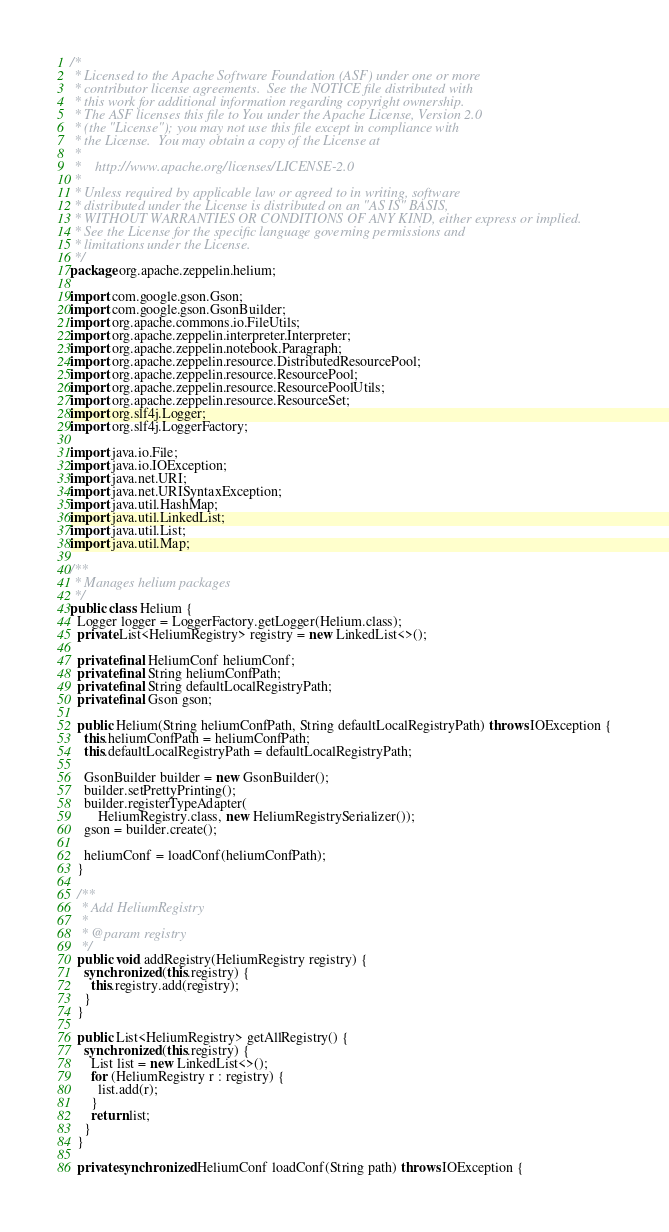Convert code to text. <code><loc_0><loc_0><loc_500><loc_500><_Java_>/*
 * Licensed to the Apache Software Foundation (ASF) under one or more
 * contributor license agreements.  See the NOTICE file distributed with
 * this work for additional information regarding copyright ownership.
 * The ASF licenses this file to You under the Apache License, Version 2.0
 * (the "License"); you may not use this file except in compliance with
 * the License.  You may obtain a copy of the License at
 *
 *    http://www.apache.org/licenses/LICENSE-2.0
 *
 * Unless required by applicable law or agreed to in writing, software
 * distributed under the License is distributed on an "AS IS" BASIS,
 * WITHOUT WARRANTIES OR CONDITIONS OF ANY KIND, either express or implied.
 * See the License for the specific language governing permissions and
 * limitations under the License.
 */
package org.apache.zeppelin.helium;

import com.google.gson.Gson;
import com.google.gson.GsonBuilder;
import org.apache.commons.io.FileUtils;
import org.apache.zeppelin.interpreter.Interpreter;
import org.apache.zeppelin.notebook.Paragraph;
import org.apache.zeppelin.resource.DistributedResourcePool;
import org.apache.zeppelin.resource.ResourcePool;
import org.apache.zeppelin.resource.ResourcePoolUtils;
import org.apache.zeppelin.resource.ResourceSet;
import org.slf4j.Logger;
import org.slf4j.LoggerFactory;

import java.io.File;
import java.io.IOException;
import java.net.URI;
import java.net.URISyntaxException;
import java.util.HashMap;
import java.util.LinkedList;
import java.util.List;
import java.util.Map;

/**
 * Manages helium packages
 */
public class Helium {
  Logger logger = LoggerFactory.getLogger(Helium.class);
  private List<HeliumRegistry> registry = new LinkedList<>();

  private final HeliumConf heliumConf;
  private final String heliumConfPath;
  private final String defaultLocalRegistryPath;
  private final Gson gson;

  public Helium(String heliumConfPath, String defaultLocalRegistryPath) throws IOException {
    this.heliumConfPath = heliumConfPath;
    this.defaultLocalRegistryPath = defaultLocalRegistryPath;

    GsonBuilder builder = new GsonBuilder();
    builder.setPrettyPrinting();
    builder.registerTypeAdapter(
        HeliumRegistry.class, new HeliumRegistrySerializer());
    gson = builder.create();

    heliumConf = loadConf(heliumConfPath);
  }

  /**
   * Add HeliumRegistry
   *
   * @param registry
   */
  public void addRegistry(HeliumRegistry registry) {
    synchronized (this.registry) {
      this.registry.add(registry);
    }
  }

  public List<HeliumRegistry> getAllRegistry() {
    synchronized (this.registry) {
      List list = new LinkedList<>();
      for (HeliumRegistry r : registry) {
        list.add(r);
      }
      return list;
    }
  }

  private synchronized HeliumConf loadConf(String path) throws IOException {</code> 